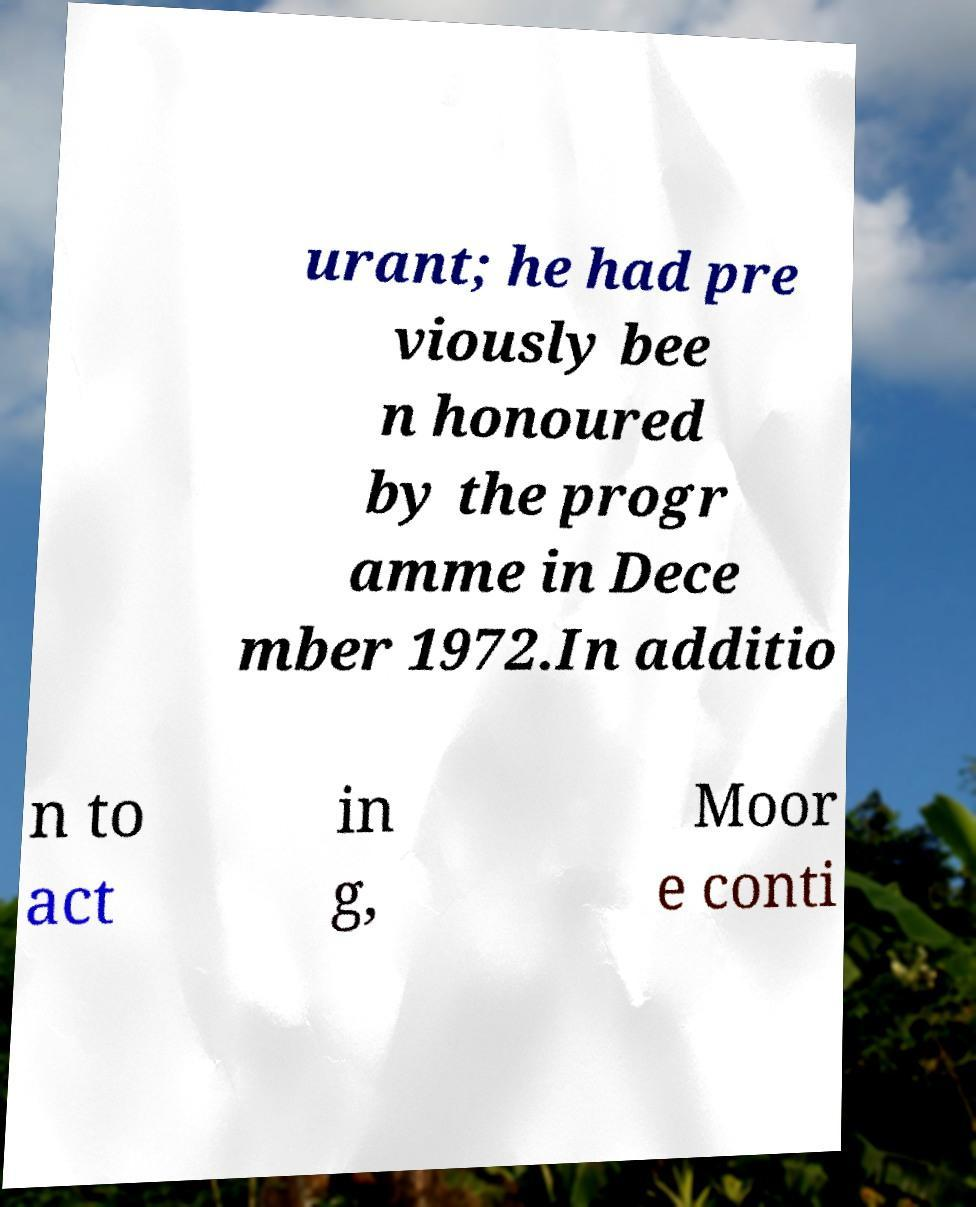I need the written content from this picture converted into text. Can you do that? urant; he had pre viously bee n honoured by the progr amme in Dece mber 1972.In additio n to act in g, Moor e conti 